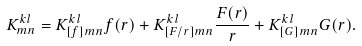<formula> <loc_0><loc_0><loc_500><loc_500>K _ { m n } ^ { k l } = K ^ { k l } _ { [ f ] m n } f ( r ) + K ^ { k l } _ { [ F / r ] m n } \frac { F ( r ) } { r } + K ^ { k l } _ { [ G ] m n } G ( r ) .</formula> 